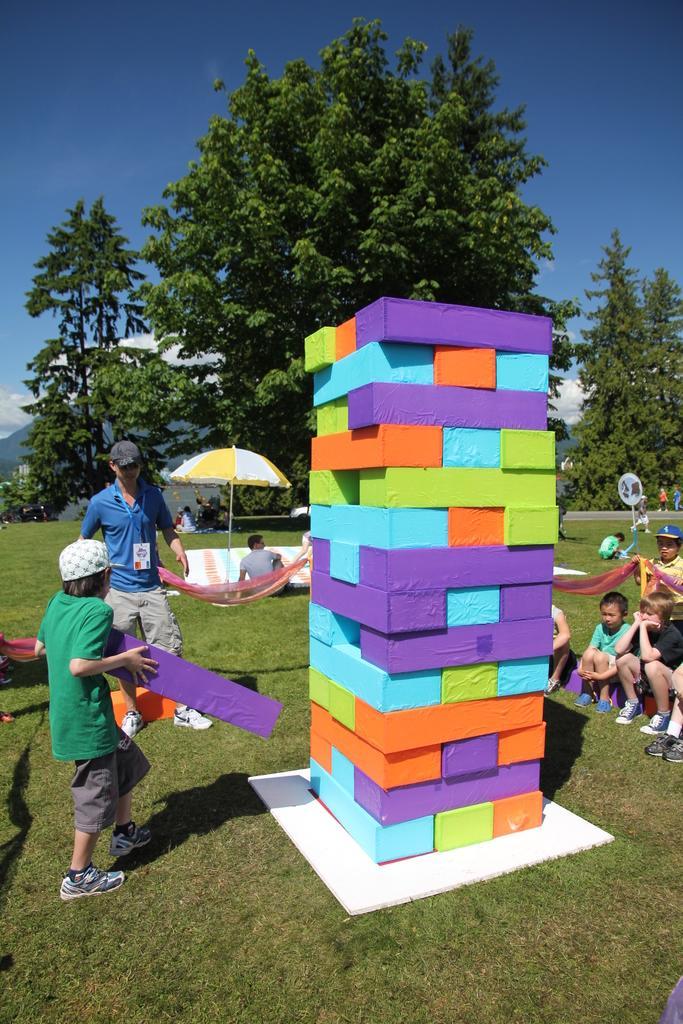Can you describe this image briefly? In this image at the center there is a building block. Beside that children are sitting on the surface of the grass. At the background there are trees and sky. 